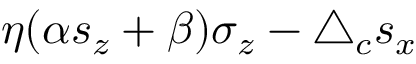<formula> <loc_0><loc_0><loc_500><loc_500>\eta ( \alpha s _ { z } + \beta ) \sigma _ { z } - \bigtriangleup _ { c } s _ { x }</formula> 